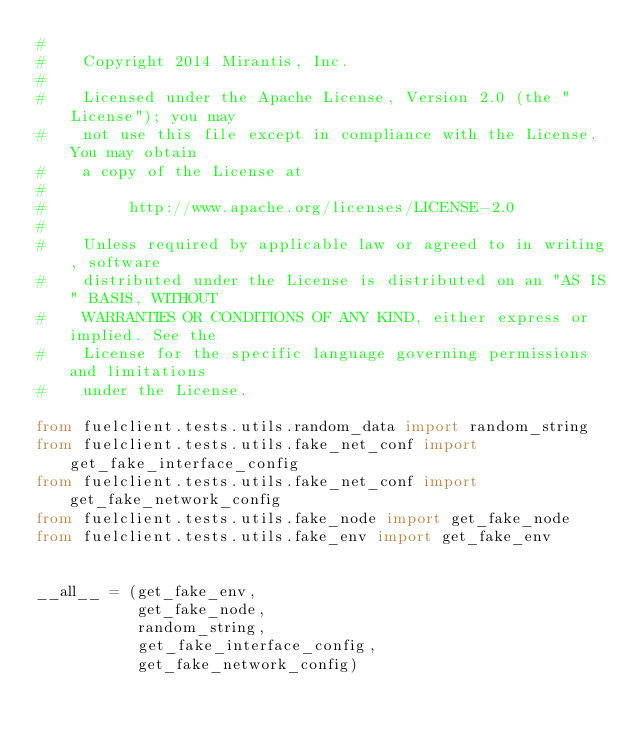<code> <loc_0><loc_0><loc_500><loc_500><_Python_>#
#    Copyright 2014 Mirantis, Inc.
#
#    Licensed under the Apache License, Version 2.0 (the "License"); you may
#    not use this file except in compliance with the License. You may obtain
#    a copy of the License at
#
#         http://www.apache.org/licenses/LICENSE-2.0
#
#    Unless required by applicable law or agreed to in writing, software
#    distributed under the License is distributed on an "AS IS" BASIS, WITHOUT
#    WARRANTIES OR CONDITIONS OF ANY KIND, either express or implied. See the
#    License for the specific language governing permissions and limitations
#    under the License.

from fuelclient.tests.utils.random_data import random_string
from fuelclient.tests.utils.fake_net_conf import get_fake_interface_config
from fuelclient.tests.utils.fake_net_conf import get_fake_network_config
from fuelclient.tests.utils.fake_node import get_fake_node
from fuelclient.tests.utils.fake_env import get_fake_env


__all__ = (get_fake_env,
           get_fake_node,
           random_string,
           get_fake_interface_config,
           get_fake_network_config)
</code> 